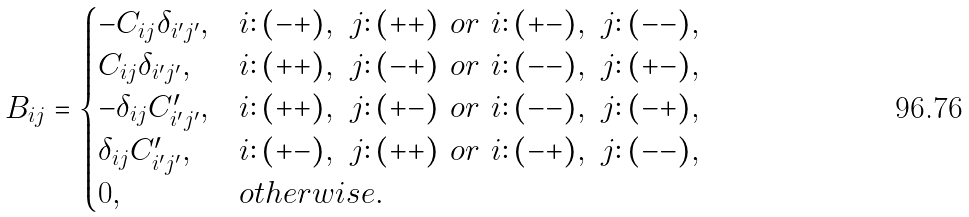<formula> <loc_0><loc_0><loc_500><loc_500>B _ { i j } = \begin{cases} - C _ { i j } \delta _ { i ^ { \prime } j ^ { \prime } } , & i \colon ( - + ) , \ j \colon ( + + ) \ o r \ i \colon ( + - ) , \ j \colon ( - - ) , \\ C _ { i j } \delta _ { i ^ { \prime } j ^ { \prime } } , & i \colon ( + + ) , \ j \colon ( - + ) \ o r \ i \colon ( - - ) , \ j \colon ( + - ) , \\ - \delta _ { i j } C ^ { \prime } _ { i ^ { \prime } j ^ { \prime } } , & i \colon ( + + ) , \ j \colon ( + - ) \ o r \ i \colon ( - - ) , \ j \colon ( - + ) , \\ \delta _ { i j } C ^ { \prime } _ { i ^ { \prime } j ^ { \prime } } , & i \colon ( + - ) , \ j \colon ( + + ) \ o r \ i \colon ( - + ) , \ j \colon ( - - ) , \\ 0 , & o t h e r w i s e . \end{cases}</formula> 